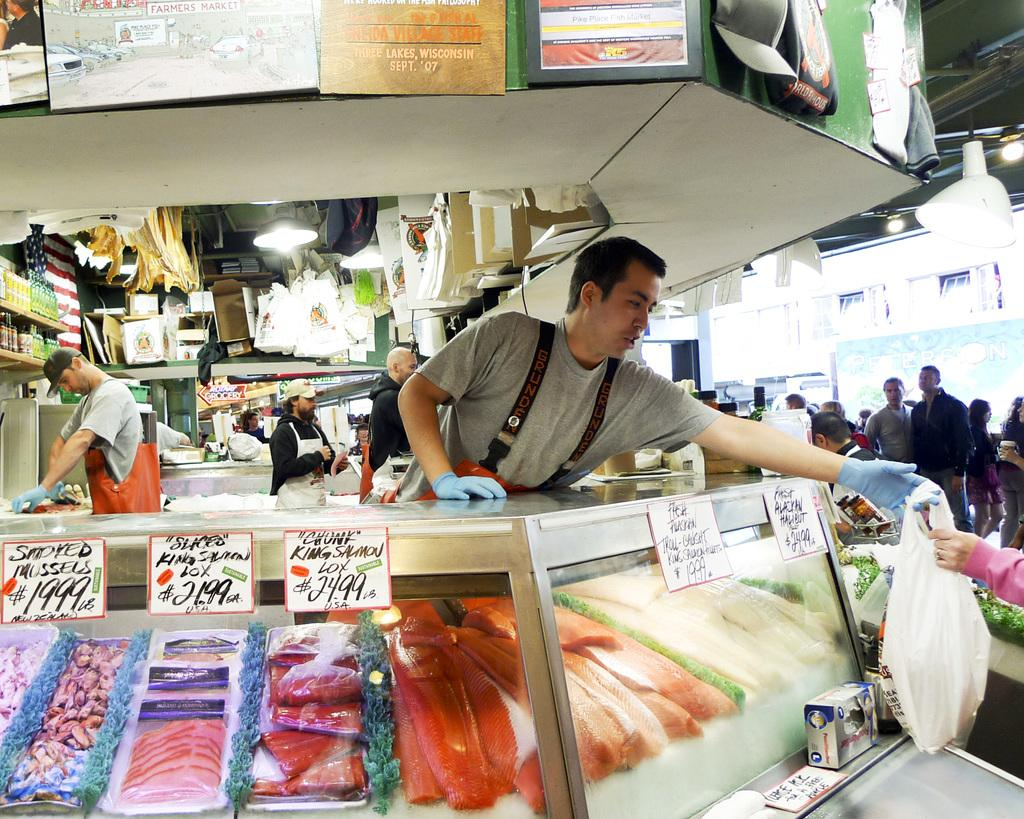<image>
Create a compact narrative representing the image presented. A seafood market with various prices, namely $21.99, $24.99 among others. 